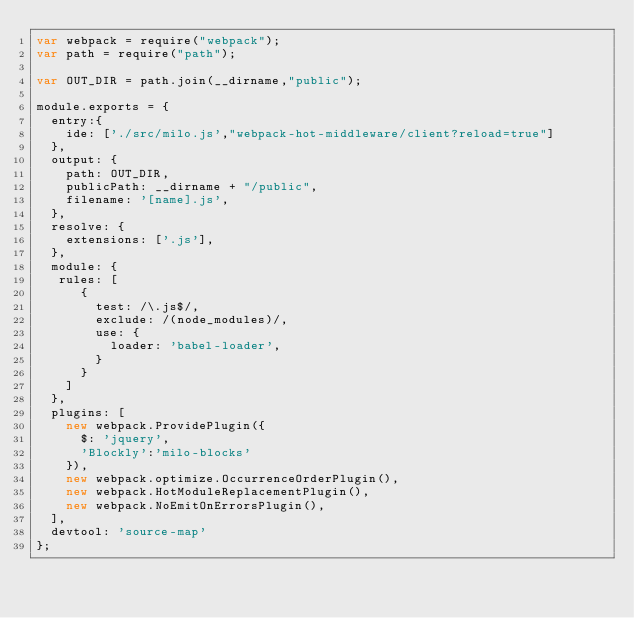<code> <loc_0><loc_0><loc_500><loc_500><_JavaScript_>var webpack = require("webpack");
var path = require("path");

var OUT_DIR = path.join(__dirname,"public");

module.exports = {
  entry:{
    ide: ['./src/milo.js',"webpack-hot-middleware/client?reload=true"]
  },
  output: {
    path: OUT_DIR,
    publicPath: __dirname + "/public",
    filename: '[name].js',
  },
  resolve: {
    extensions: ['.js'],
  },
  module: {
   rules: [
      {
        test: /\.js$/,
        exclude: /(node_modules)/,
        use: {
          loader: 'babel-loader',
        }
      }
    ]
  },
  plugins: [
    new webpack.ProvidePlugin({
      $: 'jquery',
      'Blockly':'milo-blocks'
    }),
    new webpack.optimize.OccurrenceOrderPlugin(),
    new webpack.HotModuleReplacementPlugin(),
    new webpack.NoEmitOnErrorsPlugin(),
  ],
  devtool: 'source-map'
};
</code> 